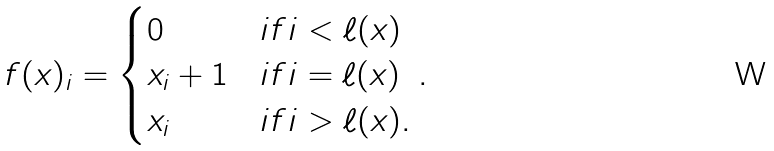Convert formula to latex. <formula><loc_0><loc_0><loc_500><loc_500>f ( x ) _ { i } = \begin{cases} 0 & i f i < \ell ( x ) \\ x _ { i } + 1 & i f i = \ell ( x ) \\ x _ { i } & i f i > \ell ( x ) . \end{cases} .</formula> 